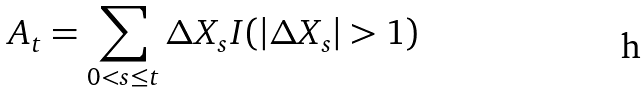Convert formula to latex. <formula><loc_0><loc_0><loc_500><loc_500>A _ { t } = \sum _ { 0 < s \leq t } \Delta X _ { s } I ( | \Delta X _ { s } | > 1 )</formula> 